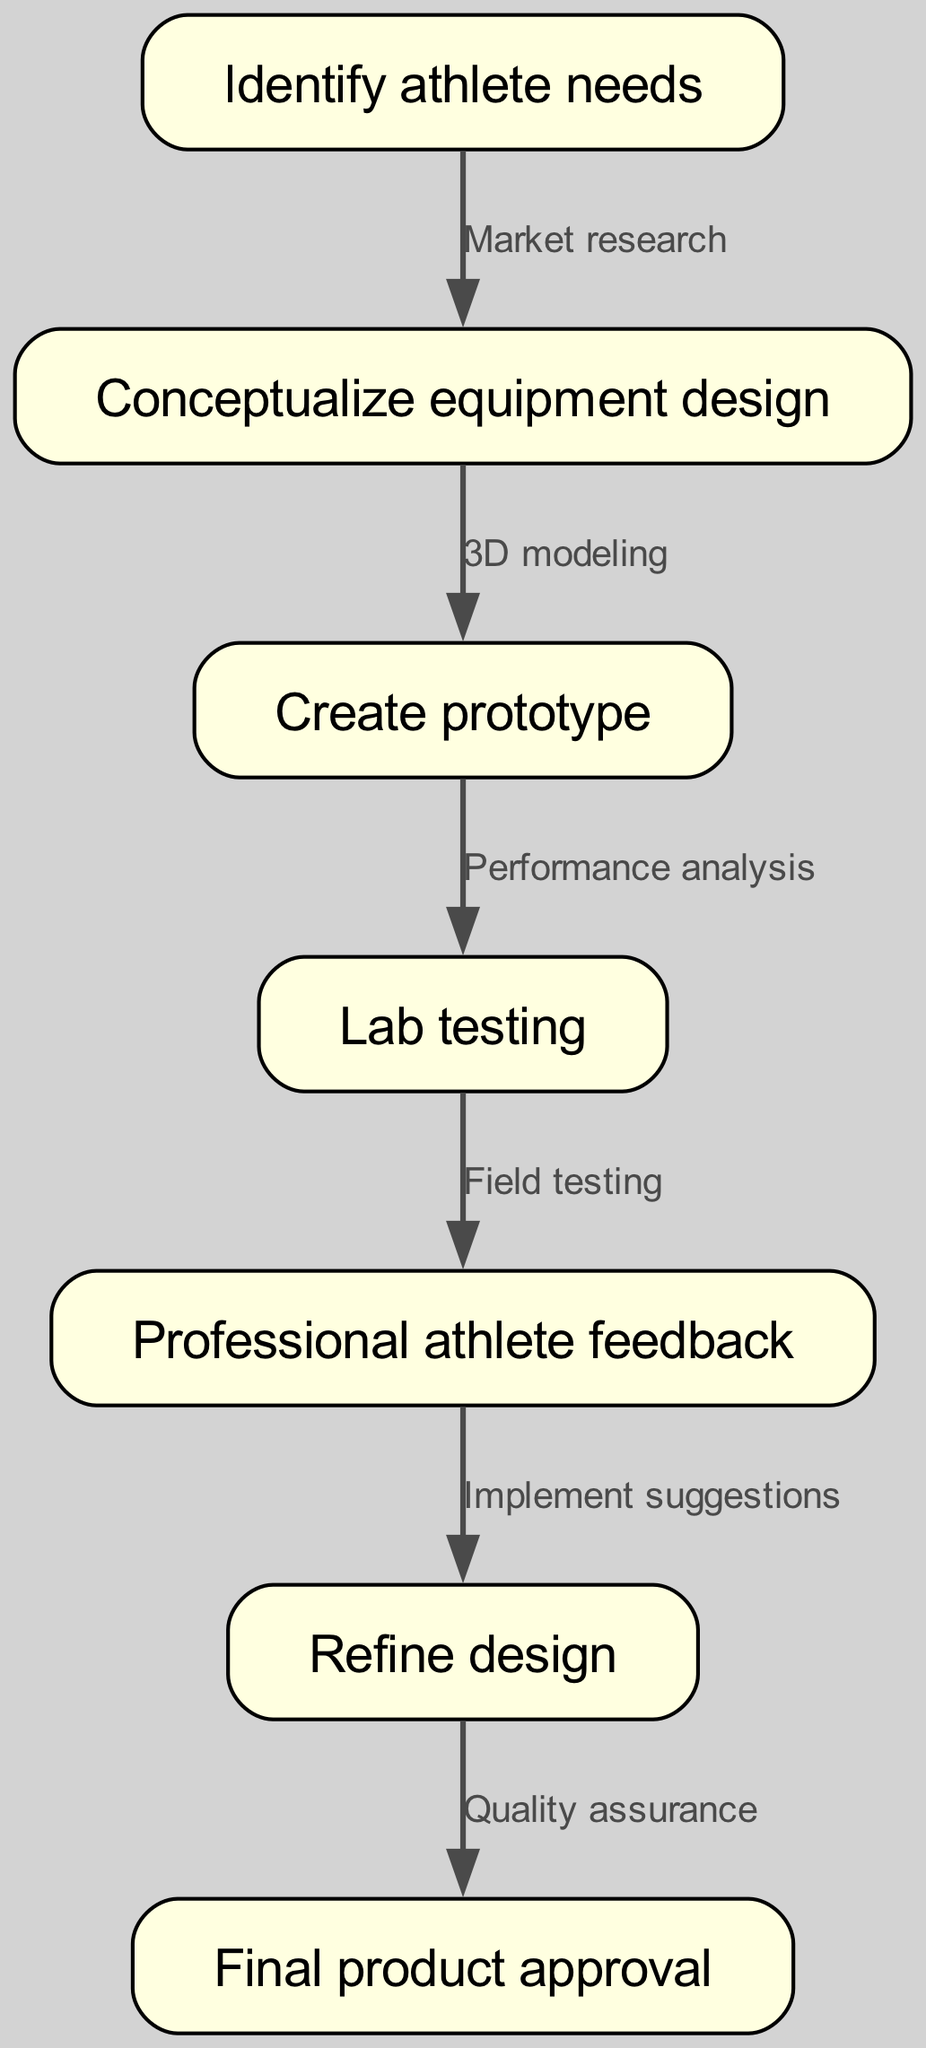What is the first step in the design process? The flowchart starts with the node labeled "Identify athlete needs," indicating that this is the first step in the process.
Answer: Identify athlete needs How many total nodes are in the diagram? By counting the individual nodes in the diagram provided, there are seven nodes, representing different steps in the process.
Answer: 7 What is the edge label between identifying needs and conceptualizing design? The edge that connects "Identify athlete needs" to "Conceptualize equipment design" is labeled "Market research," which signifies the method used to move from the first step to the second.
Answer: Market research Which node comes after "Lab testing"? Following the "Lab testing" node, the next node in the flowchart is "Professional athlete feedback," indicating this step occurs directly after testing in the flow.
Answer: Professional athlete feedback What is the final step before product approval? The step just before "Final product approval" is labeled "Refine design," showing that this step must be completed prior to getting approval for the product.
Answer: Refine design What do you need to implement after gathering professional athlete feedback? After receiving "Professional athlete feedback," the next step is to "Implement suggestions," which indicates that the feedback must be acted upon.
Answer: Implement suggestions What method is used to create the prototype? The edge leading from "Conceptualize equipment design" to "Create prototype" is identified as "3D modeling," indicating the specific approach taken to develop the prototype.
Answer: 3D modeling How does performance analysis fit into the flowchart? The node "Performance analysis" directly connects the prototype creation to lab testing, highlighting that this analysis is necessary for assessing the prototype before testing.
Answer: Performance analysis 